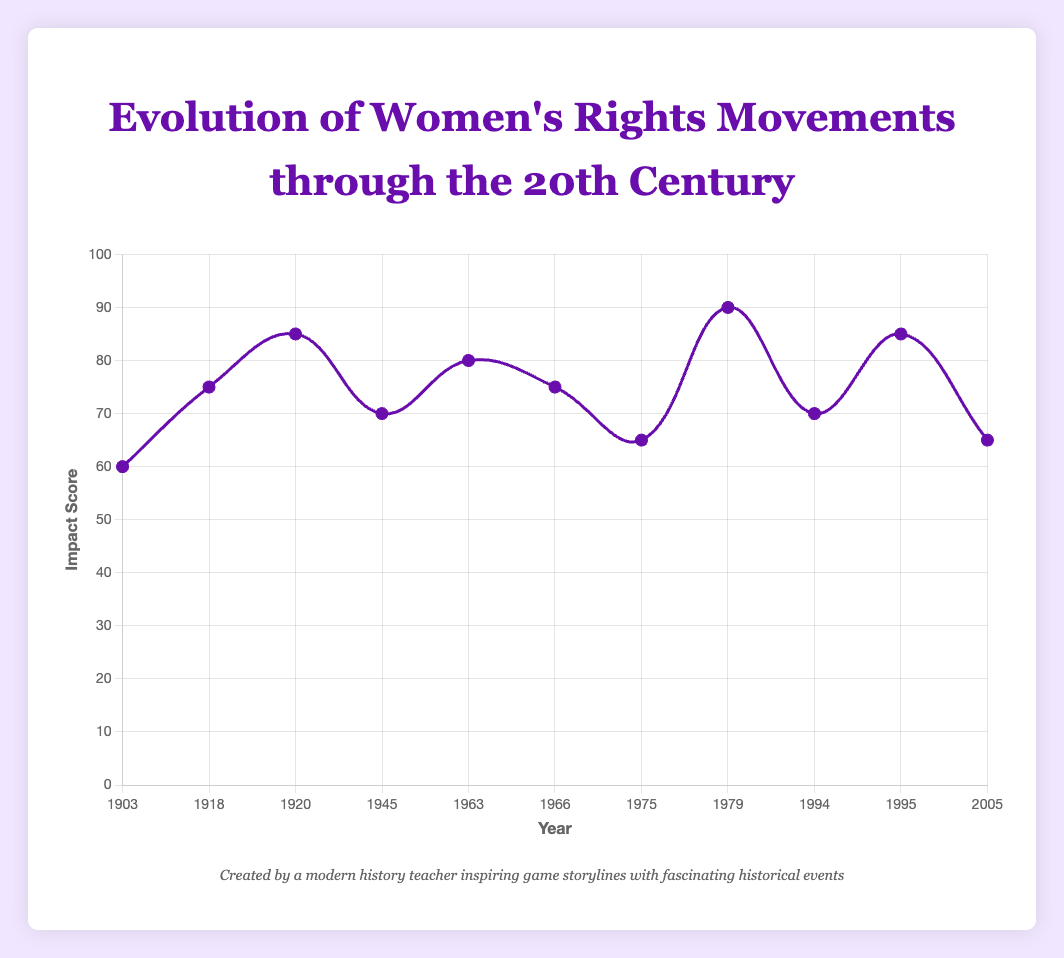What is the peak impact score reached during the 20th century? To determine the peak impact score, we examine the highest point on the curve, which occurs in 1979 with the Convention on the Elimination of All Forms of Discrimination Against Women (CEDAW) event having a score of 90.
Answer: 90 Which year has a higher impact score: 1966 or 1994? Comparing the impact scores for these two years, 1966 has an impact score of 75, and 1994 has an impact score of 70. Therefore, 1966 has a higher impact score.
Answer: 1966 What is the average impact score from the years 1903 to 1975? First, sum the impact scores of the given years: 60 (1903) + 75 (1918) + 85 (1920) + 70 (1945) + 80 (1963) + 75 (1966) + 65 (1975) = 510. There are 7 data points, so the average is 510 / 7 ≈ 72.86.
Answer: 72.86 In which decade was the most significant increase in the impact score observed? Looking at the differences between each pair of consecutive years, the largest increase is between 1975 and 1979, where the score goes from 65 to 90, an increase of 25 points.
Answer: 1970s Compare the trend from 1945 to 1966 with the trend from 1979 to 2005. Which period shows a more consistent pattern? From 1945 to 1966, the scores fluctuate between 70 (1945), 80 (1963), and 75 (1966). From 1979 to 2005, the scores are 90 (1979), 70 (1994), 85 (1995), and 65 (2005). The period from 1945 to 1966 shows a more consistent pattern despite small fluctuations, whereas the latter period shows larger variations.
Answer: 1945 to 1966 Between which two consecutive years was the greatest decrease in the impact score observed? To find this, compare the impact scores: the largest decrease is from 1979 (90) to 1994 (70), resulting in a decrease of 20 points.
Answer: 1979 to 1994 